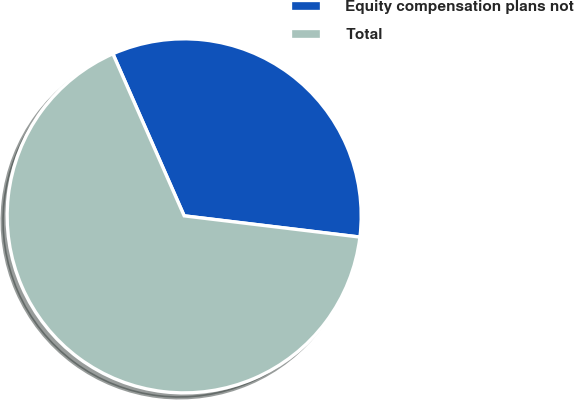Convert chart to OTSL. <chart><loc_0><loc_0><loc_500><loc_500><pie_chart><fcel>Equity compensation plans not<fcel>Total<nl><fcel>33.51%<fcel>66.49%<nl></chart> 